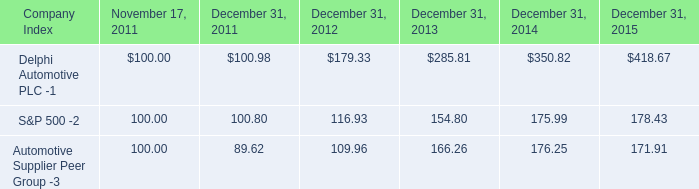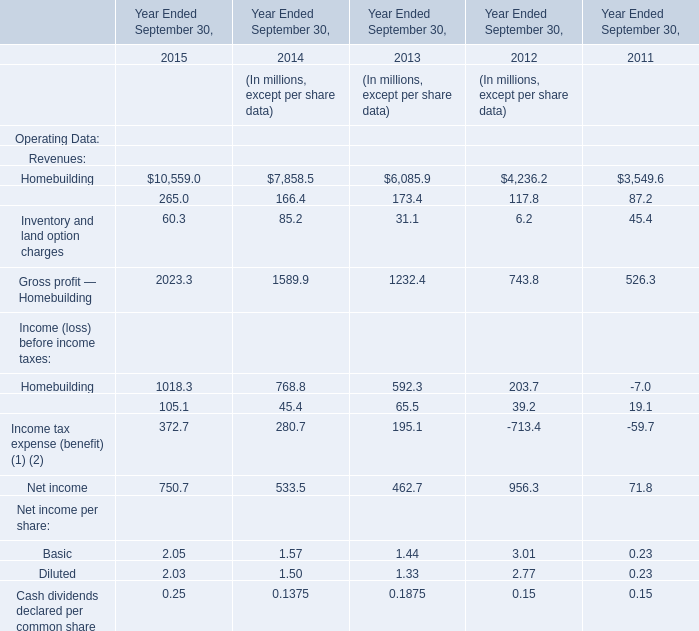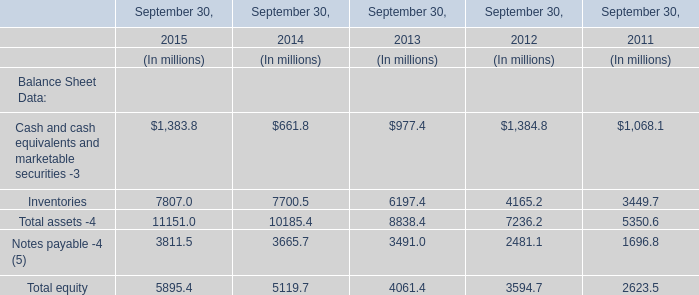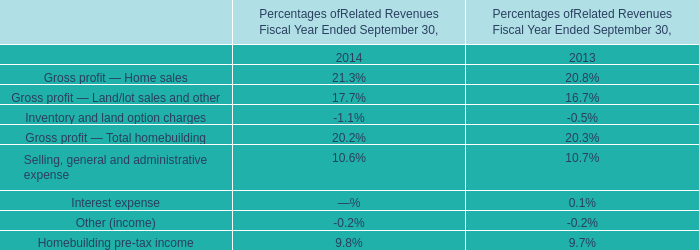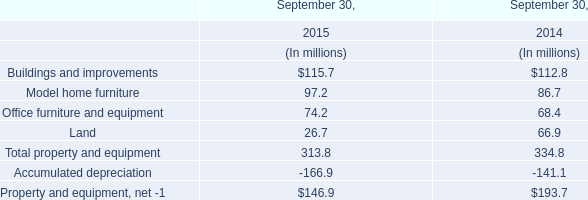What was the average of the Total equity in the years where Inventories is positive? (in million) 
Computations: (((((5895.4 + 5119.7) + 4061.4) + 3594.7) + 2623.5) / 5)
Answer: 4258.94. 